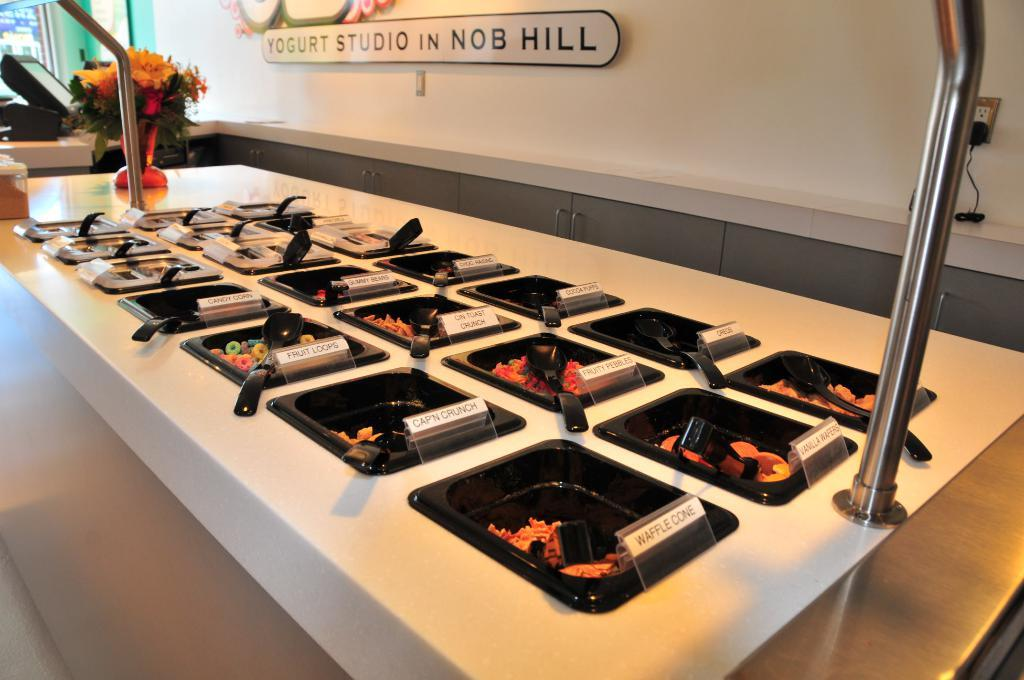<image>
Summarize the visual content of the image. A buffet spread at Yogurt Studio in Nob Hill 